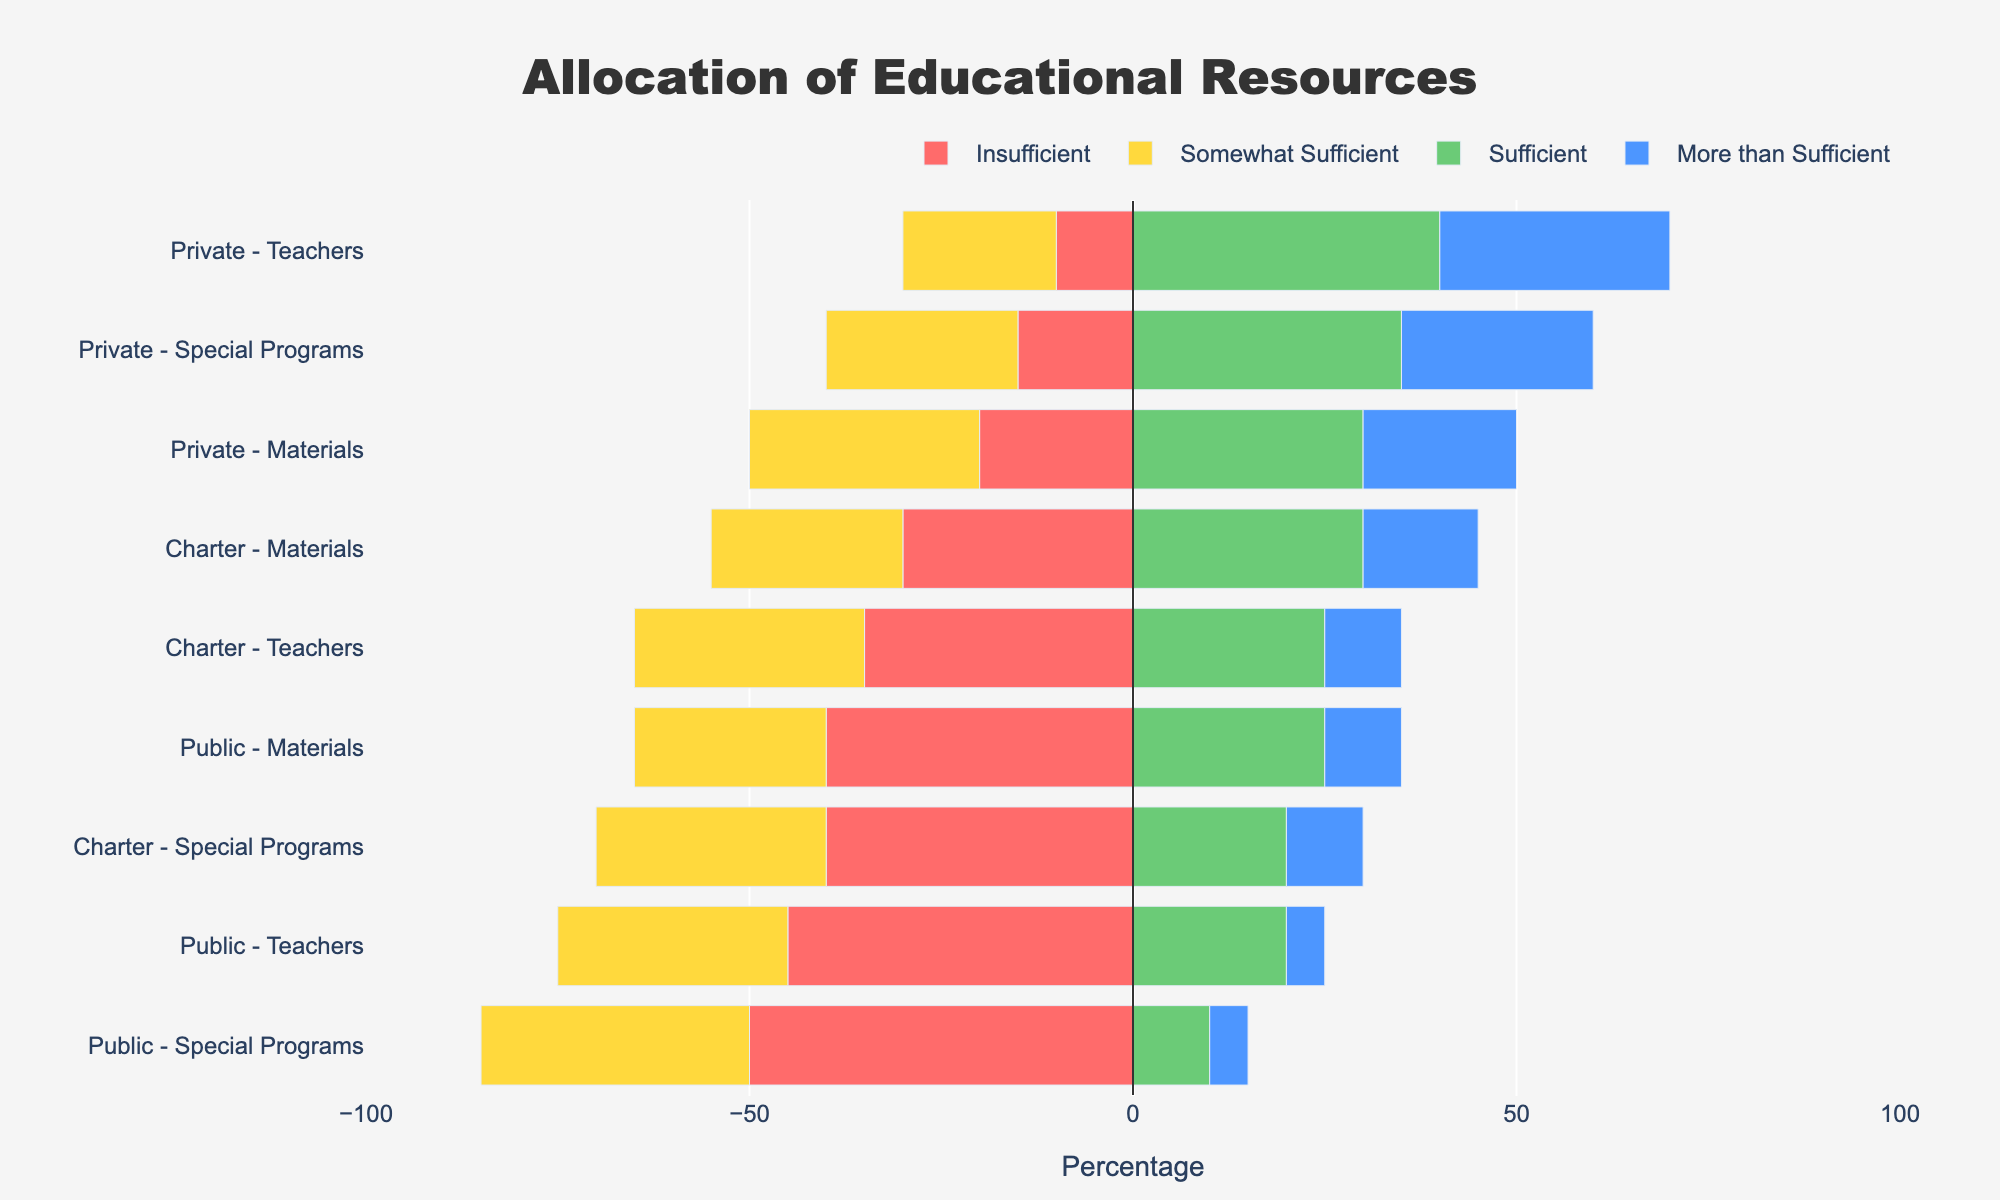What's the percentage of public schools that find teachers insufficient? The diverging stacked bar chart shows that the percentage of public schools that find teachers insufficient is represented by the red bar. Observing the length of the red bar corresponding to public schools and teachers, we can see it reaches 45%.
Answer: 45% Which school type has the highest percentage of sufficient special programs? According to the chart, "Sufficient" is colored green. By comparing the length of the green bars among public, private, and charter schools for special programs, we see that private schools have the longest green bar labeled for special programs at 35%.
Answer: Private How does the sufficiency of materials in charter schools compare to public schools? Compare the lengths of each sufficiency level for materials between charter and public schools. Charter schools have fewer insufficient materials (30%) compared to public schools (40%), and more 'More than Sufficient' materials (15% vs 10%). However, more public schools have 'Sufficient' materials (25% vs 30%).
Answer: Charter schools generally show a better distribution in materials sufficiency than public schools What is the combined percentage of private schools that find teachers either sufficient or more than sufficient? Look at private schools' bars for teachers. The green bar (sufficient) and blue bar (more than sufficient) for private schools are 40% and 30%, respectively. Add these percentages together: 40% + 30% = 70%.
Answer: 70% Which resource type shows the highest insufficiency in public schools? Insufficient resources are colored red. Among the public school resource types, the bar for special programs shows higher insufficiency at 50% compared to teachers (45%) and materials (40%).
Answer: Special programs Among charter schools, what percentage do not find teachers sufficient? For charter schools' teachers, sum the "Insufficient" (35%) and "Somewhat Sufficient" (30%) categories. Therefore, 35% + 30% = 65%.
Answer: 65% How do materials in private schools fare compared to public and charter schools in terms of 'more than sufficient'? Look at the blue bars representing 'more than sufficient' materials. Private schools lead with 20%, followed by charter schools at 15%, and public schools have 10%.
Answer: Private schools have the highest percentage Which resource type shows the least sufficiency in charter schools? For each resource type (teachers, special programs, materials) in charter schools, check the green ('Sufficient') and blue ('More than Sufficient') bars. Special programs show the least sufficiency since 'Sufficient' and 'More than Sufficient' percentages are lower (20% and 10%) compared to other types.
Answer: Special programs Among the school types, which has the highest distribution in 'More than Sufficient' category for teachers? Look at the blue bars for teachers across school types. Private schools show the longest blue bar at 30%.
Answer: Private schools 